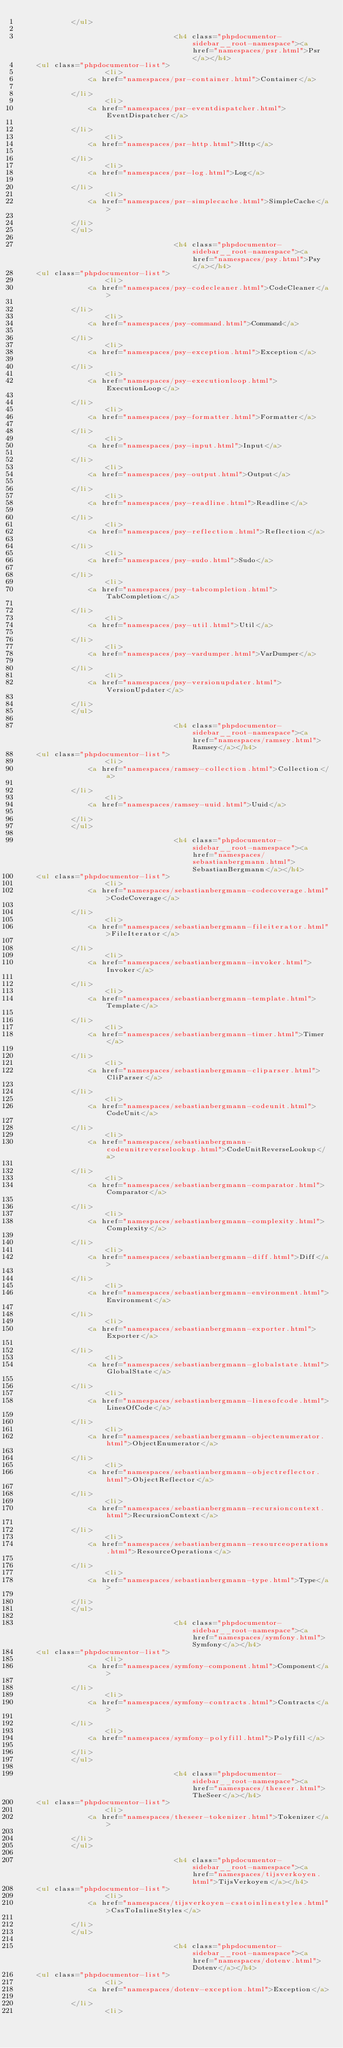Convert code to text. <code><loc_0><loc_0><loc_500><loc_500><_HTML_>            </ul>

                                    <h4 class="phpdocumentor-sidebar__root-namespace"><a href="namespaces/psr.html">Psr</a></h4>
    <ul class="phpdocumentor-list">
                    <li>
                <a href="namespaces/psr-container.html">Container</a>
                
            </li>
                    <li>
                <a href="namespaces/psr-eventdispatcher.html">EventDispatcher</a>
                
            </li>
                    <li>
                <a href="namespaces/psr-http.html">Http</a>
                
            </li>
                    <li>
                <a href="namespaces/psr-log.html">Log</a>
                
            </li>
                    <li>
                <a href="namespaces/psr-simplecache.html">SimpleCache</a>
                
            </li>
            </ul>

                                    <h4 class="phpdocumentor-sidebar__root-namespace"><a href="namespaces/psy.html">Psy</a></h4>
    <ul class="phpdocumentor-list">
                    <li>
                <a href="namespaces/psy-codecleaner.html">CodeCleaner</a>
                
            </li>
                    <li>
                <a href="namespaces/psy-command.html">Command</a>
                
            </li>
                    <li>
                <a href="namespaces/psy-exception.html">Exception</a>
                
            </li>
                    <li>
                <a href="namespaces/psy-executionloop.html">ExecutionLoop</a>
                
            </li>
                    <li>
                <a href="namespaces/psy-formatter.html">Formatter</a>
                
            </li>
                    <li>
                <a href="namespaces/psy-input.html">Input</a>
                
            </li>
                    <li>
                <a href="namespaces/psy-output.html">Output</a>
                
            </li>
                    <li>
                <a href="namespaces/psy-readline.html">Readline</a>
                
            </li>
                    <li>
                <a href="namespaces/psy-reflection.html">Reflection</a>
                
            </li>
                    <li>
                <a href="namespaces/psy-sudo.html">Sudo</a>
                
            </li>
                    <li>
                <a href="namespaces/psy-tabcompletion.html">TabCompletion</a>
                
            </li>
                    <li>
                <a href="namespaces/psy-util.html">Util</a>
                
            </li>
                    <li>
                <a href="namespaces/psy-vardumper.html">VarDumper</a>
                
            </li>
                    <li>
                <a href="namespaces/psy-versionupdater.html">VersionUpdater</a>
                
            </li>
            </ul>

                                    <h4 class="phpdocumentor-sidebar__root-namespace"><a href="namespaces/ramsey.html">Ramsey</a></h4>
    <ul class="phpdocumentor-list">
                    <li>
                <a href="namespaces/ramsey-collection.html">Collection</a>
                
            </li>
                    <li>
                <a href="namespaces/ramsey-uuid.html">Uuid</a>
                
            </li>
            </ul>

                                    <h4 class="phpdocumentor-sidebar__root-namespace"><a href="namespaces/sebastianbergmann.html">SebastianBergmann</a></h4>
    <ul class="phpdocumentor-list">
                    <li>
                <a href="namespaces/sebastianbergmann-codecoverage.html">CodeCoverage</a>
                
            </li>
                    <li>
                <a href="namespaces/sebastianbergmann-fileiterator.html">FileIterator</a>
                
            </li>
                    <li>
                <a href="namespaces/sebastianbergmann-invoker.html">Invoker</a>
                
            </li>
                    <li>
                <a href="namespaces/sebastianbergmann-template.html">Template</a>
                
            </li>
                    <li>
                <a href="namespaces/sebastianbergmann-timer.html">Timer</a>
                
            </li>
                    <li>
                <a href="namespaces/sebastianbergmann-cliparser.html">CliParser</a>
                
            </li>
                    <li>
                <a href="namespaces/sebastianbergmann-codeunit.html">CodeUnit</a>
                
            </li>
                    <li>
                <a href="namespaces/sebastianbergmann-codeunitreverselookup.html">CodeUnitReverseLookup</a>
                
            </li>
                    <li>
                <a href="namespaces/sebastianbergmann-comparator.html">Comparator</a>
                
            </li>
                    <li>
                <a href="namespaces/sebastianbergmann-complexity.html">Complexity</a>
                
            </li>
                    <li>
                <a href="namespaces/sebastianbergmann-diff.html">Diff</a>
                
            </li>
                    <li>
                <a href="namespaces/sebastianbergmann-environment.html">Environment</a>
                
            </li>
                    <li>
                <a href="namespaces/sebastianbergmann-exporter.html">Exporter</a>
                
            </li>
                    <li>
                <a href="namespaces/sebastianbergmann-globalstate.html">GlobalState</a>
                
            </li>
                    <li>
                <a href="namespaces/sebastianbergmann-linesofcode.html">LinesOfCode</a>
                
            </li>
                    <li>
                <a href="namespaces/sebastianbergmann-objectenumerator.html">ObjectEnumerator</a>
                
            </li>
                    <li>
                <a href="namespaces/sebastianbergmann-objectreflector.html">ObjectReflector</a>
                
            </li>
                    <li>
                <a href="namespaces/sebastianbergmann-recursioncontext.html">RecursionContext</a>
                
            </li>
                    <li>
                <a href="namespaces/sebastianbergmann-resourceoperations.html">ResourceOperations</a>
                
            </li>
                    <li>
                <a href="namespaces/sebastianbergmann-type.html">Type</a>
                
            </li>
            </ul>

                                    <h4 class="phpdocumentor-sidebar__root-namespace"><a href="namespaces/symfony.html">Symfony</a></h4>
    <ul class="phpdocumentor-list">
                    <li>
                <a href="namespaces/symfony-component.html">Component</a>
                
            </li>
                    <li>
                <a href="namespaces/symfony-contracts.html">Contracts</a>
                
            </li>
                    <li>
                <a href="namespaces/symfony-polyfill.html">Polyfill</a>
                
            </li>
            </ul>

                                    <h4 class="phpdocumentor-sidebar__root-namespace"><a href="namespaces/theseer.html">TheSeer</a></h4>
    <ul class="phpdocumentor-list">
                    <li>
                <a href="namespaces/theseer-tokenizer.html">Tokenizer</a>
                
            </li>
            </ul>

                                    <h4 class="phpdocumentor-sidebar__root-namespace"><a href="namespaces/tijsverkoyen.html">TijsVerkoyen</a></h4>
    <ul class="phpdocumentor-list">
                    <li>
                <a href="namespaces/tijsverkoyen-csstoinlinestyles.html">CssToInlineStyles</a>
                
            </li>
            </ul>

                                    <h4 class="phpdocumentor-sidebar__root-namespace"><a href="namespaces/dotenv.html">Dotenv</a></h4>
    <ul class="phpdocumentor-list">
                    <li>
                <a href="namespaces/dotenv-exception.html">Exception</a>
                
            </li>
                    <li></code> 